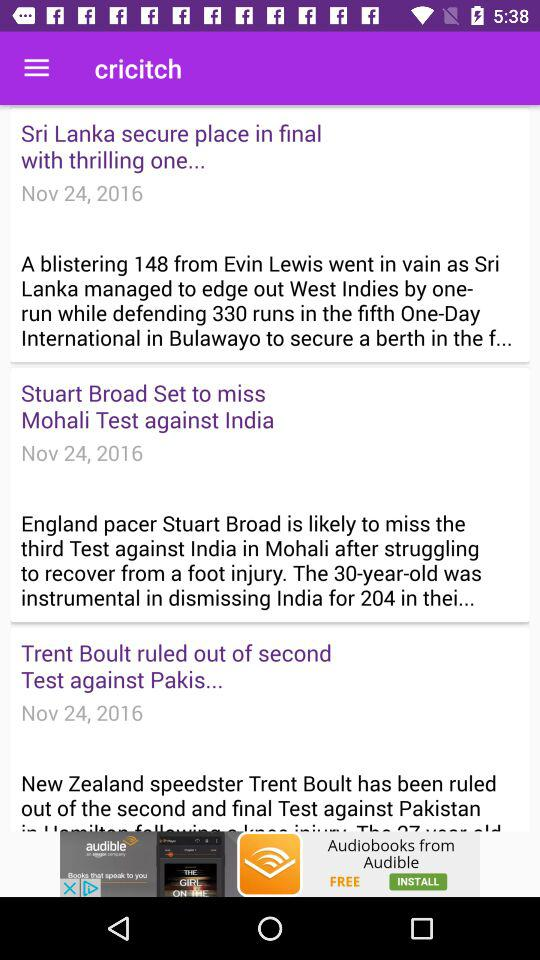What is the date of the "New Zealand" and "Pakistan" match? The date of the "New Zealand" and "Pakistan" match is from November 25, 2016 to November 29, 2016. 